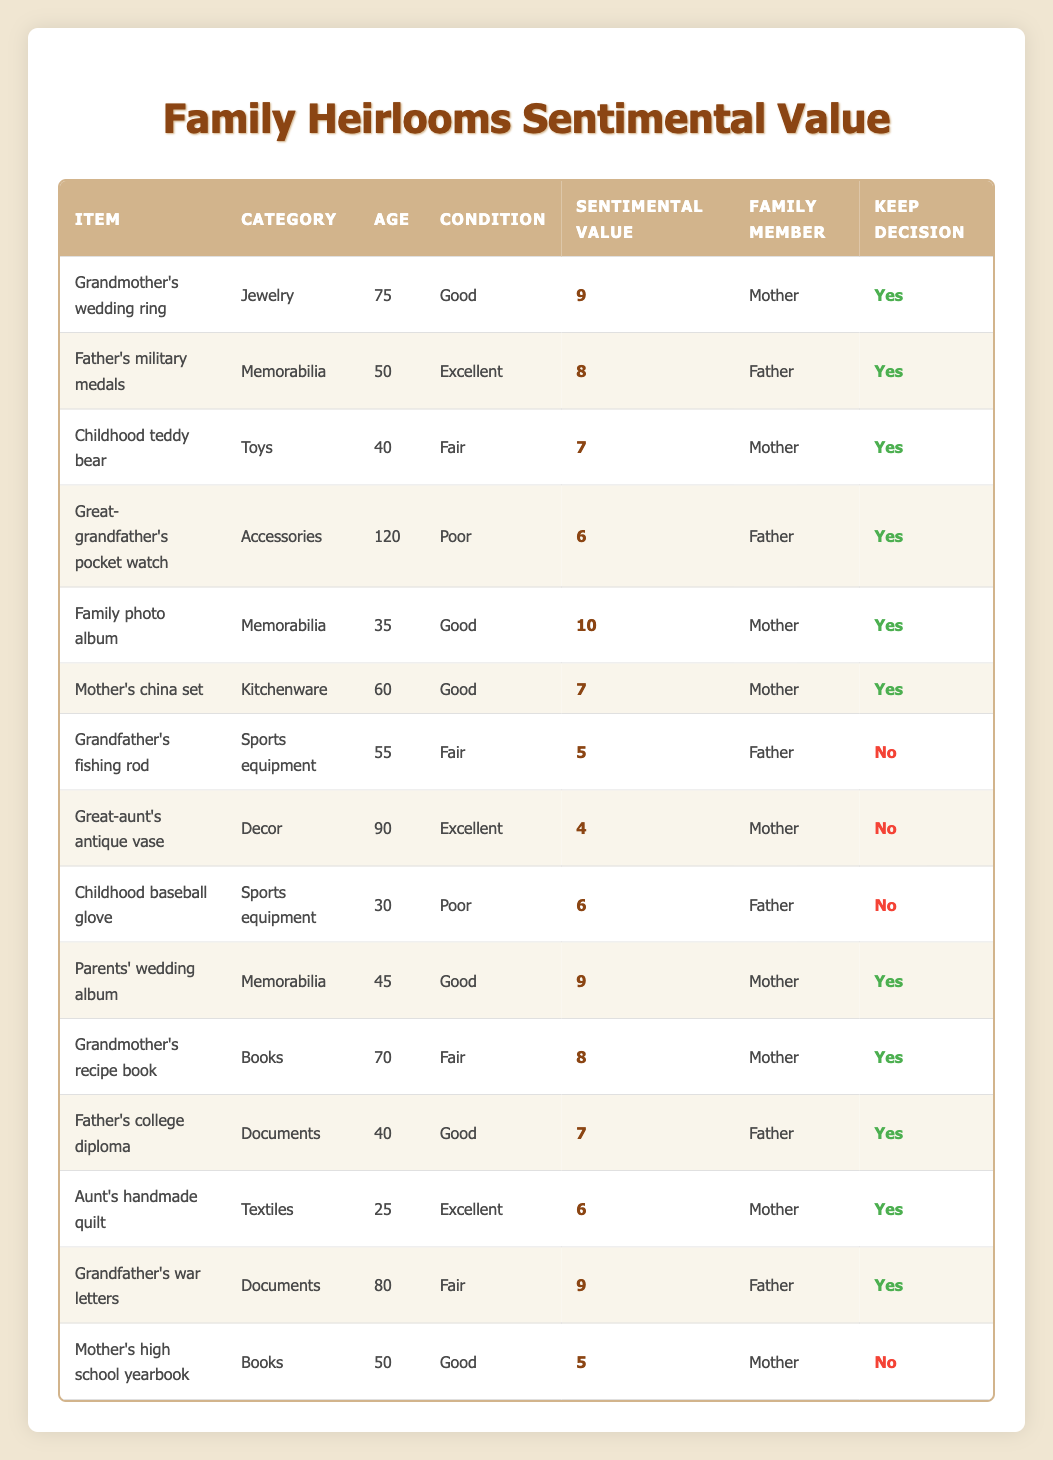What is the sentimental value of "Family photo album"? The sentimental value is listed directly in the table next to the item "Family photo album," which shows a value of 10.
Answer: 10 How many keepsakes are categorized as "Memorabilia"? There are three items in the "Memorabilia" category: "Father's military medals," "Family photo album," and "Parents' wedding album."
Answer: 3 What is the average sentimental value of the items kept? To find the average, we first identify the sentimental values of the items under "Keep Decision" as "Yes": 9, 8, 7, 10, 7, 9, 8, 7, 6, 9. Adding these values gives 81, and there are 10 items. Therefore, the average is 81/10 = 8.1.
Answer: 8.1 Is "Great-aunt's antique vase" being kept? By checking the table for the item "Great-aunt's antique vase," we see that the "Keep Decision" is marked as "No."
Answer: No What is the sentimental value of "Mother's high school yearbook"? The table shows that the sentimental value for "Mother's high school yearbook" is 5. This can be found directly in the corresponding row of the table.
Answer: 5 Which item has the highest sentimental value, and who is it associated with? By examining the sentimental values in the table, we find that "Family photo album" has the highest sentimental value of 10, and it is associated with the "Mother."
Answer: Family photo album, Mother How many items aged over 100 years are kept? From the table, we see that "Great-grandfather's pocket watch" is the only item over 100 years old. However, its "Keep Decision" is "Yes," so there is 1 item aged over 100 that is kept.
Answer: 1 Are there items in "Kitchenware" that have a sentimental value below 6? The only kitchenware item is "Mother's china set," which has a sentimental value of 7. Since there are no items below 6 in this category, the answer is "No."
Answer: No What is the total sentimental value of items that are not being kept? The sentimental values of the items not being kept are: 5 (Grandfather's fishing rod), 4 (Great-aunt's antique vase), 6 (Childhood baseball glove), and 5 (Mother's high school yearbook). Adding these values gives 5 + 4 + 6 + 5 = 20.
Answer: 20 